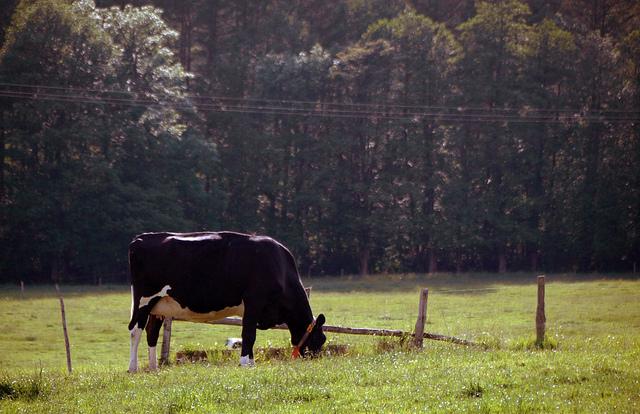Is the cow eating?
Be succinct. Yes. Is it nighttime?
Write a very short answer. No. What many black cows are there?
Concise answer only. 1. Is the animal chained to the fence?
Answer briefly. No. 